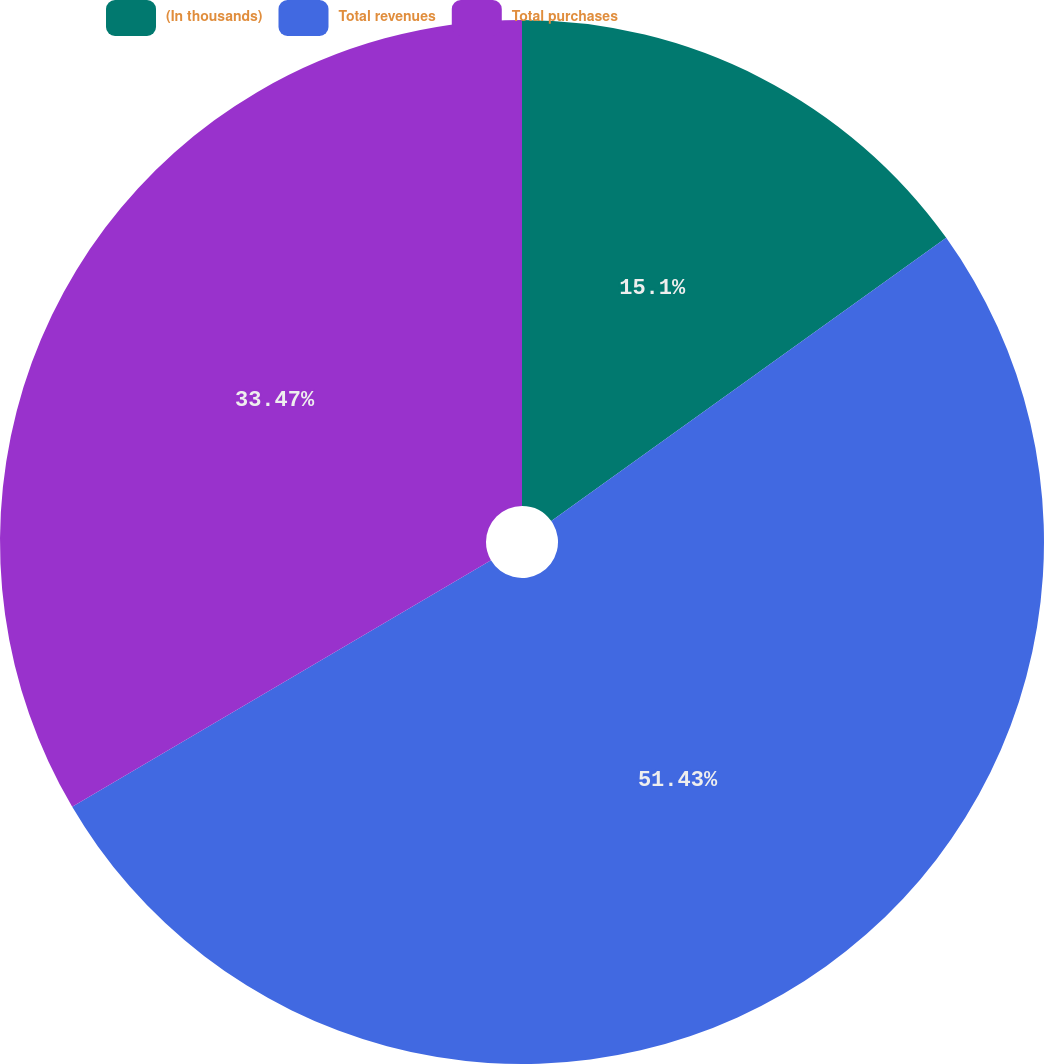Convert chart. <chart><loc_0><loc_0><loc_500><loc_500><pie_chart><fcel>(In thousands)<fcel>Total revenues<fcel>Total purchases<nl><fcel>15.1%<fcel>51.43%<fcel>33.47%<nl></chart> 